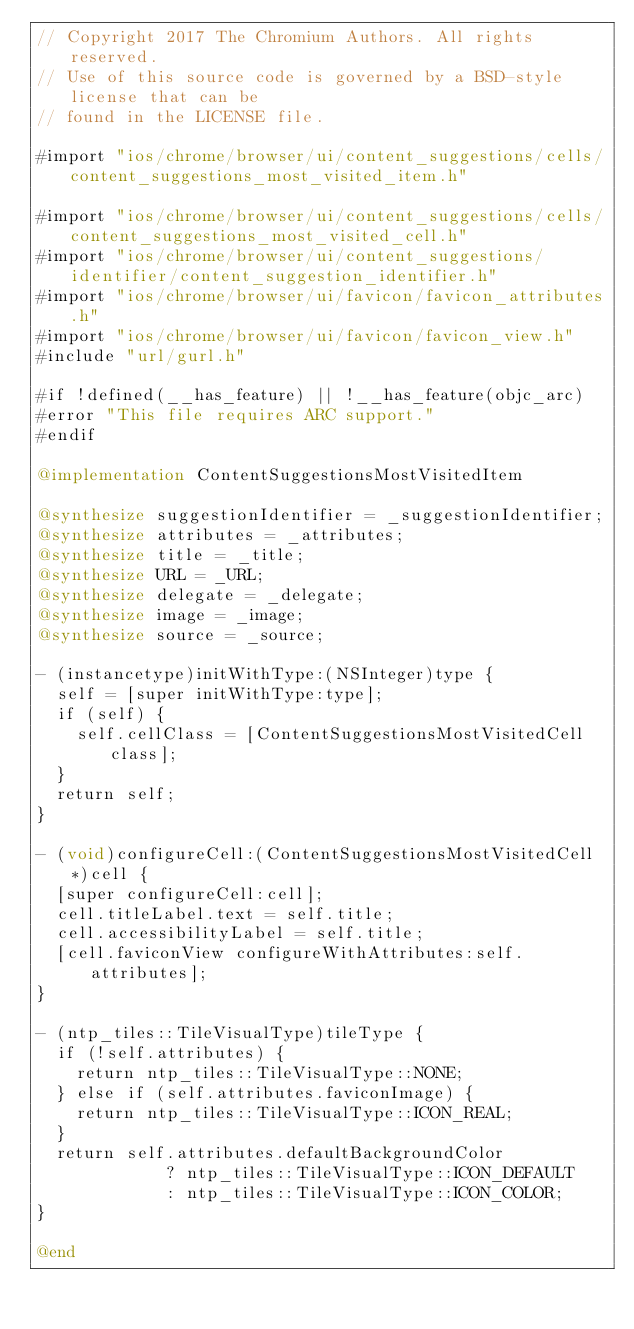Convert code to text. <code><loc_0><loc_0><loc_500><loc_500><_ObjectiveC_>// Copyright 2017 The Chromium Authors. All rights reserved.
// Use of this source code is governed by a BSD-style license that can be
// found in the LICENSE file.

#import "ios/chrome/browser/ui/content_suggestions/cells/content_suggestions_most_visited_item.h"

#import "ios/chrome/browser/ui/content_suggestions/cells/content_suggestions_most_visited_cell.h"
#import "ios/chrome/browser/ui/content_suggestions/identifier/content_suggestion_identifier.h"
#import "ios/chrome/browser/ui/favicon/favicon_attributes.h"
#import "ios/chrome/browser/ui/favicon/favicon_view.h"
#include "url/gurl.h"

#if !defined(__has_feature) || !__has_feature(objc_arc)
#error "This file requires ARC support."
#endif

@implementation ContentSuggestionsMostVisitedItem

@synthesize suggestionIdentifier = _suggestionIdentifier;
@synthesize attributes = _attributes;
@synthesize title = _title;
@synthesize URL = _URL;
@synthesize delegate = _delegate;
@synthesize image = _image;
@synthesize source = _source;

- (instancetype)initWithType:(NSInteger)type {
  self = [super initWithType:type];
  if (self) {
    self.cellClass = [ContentSuggestionsMostVisitedCell class];
  }
  return self;
}

- (void)configureCell:(ContentSuggestionsMostVisitedCell*)cell {
  [super configureCell:cell];
  cell.titleLabel.text = self.title;
  cell.accessibilityLabel = self.title;
  [cell.faviconView configureWithAttributes:self.attributes];
}

- (ntp_tiles::TileVisualType)tileType {
  if (!self.attributes) {
    return ntp_tiles::TileVisualType::NONE;
  } else if (self.attributes.faviconImage) {
    return ntp_tiles::TileVisualType::ICON_REAL;
  }
  return self.attributes.defaultBackgroundColor
             ? ntp_tiles::TileVisualType::ICON_DEFAULT
             : ntp_tiles::TileVisualType::ICON_COLOR;
}

@end
</code> 